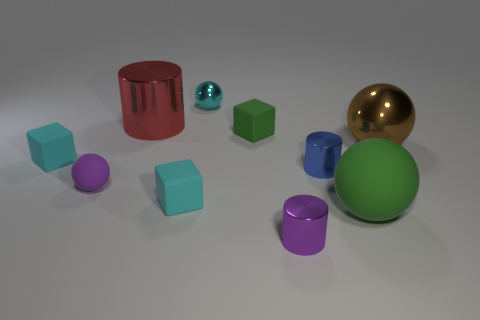Does the large matte thing have the same color as the cube that is behind the brown ball?
Make the answer very short. Yes. There is a metal object that is the same color as the tiny matte sphere; what is its shape?
Offer a terse response. Cylinder. What is the color of the matte cube in front of the cyan rubber object that is behind the block in front of the tiny blue cylinder?
Your answer should be compact. Cyan. Are there any small purple things of the same shape as the blue metallic object?
Your answer should be very brief. Yes. How many cyan metal things are there?
Provide a short and direct response. 1. What is the shape of the big green matte object?
Your response must be concise. Sphere. What number of purple metallic objects are the same size as the cyan shiny sphere?
Ensure brevity in your answer.  1. Do the purple metallic object and the big red thing have the same shape?
Ensure brevity in your answer.  Yes. The big object right of the rubber ball right of the purple matte sphere is what color?
Your answer should be compact. Brown. What is the size of the sphere that is in front of the small green rubber thing and to the left of the purple metallic object?
Your answer should be very brief. Small. 